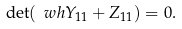<formula> <loc_0><loc_0><loc_500><loc_500>\det ( \ w h Y _ { 1 1 } + Z _ { 1 1 } ) = 0 .</formula> 